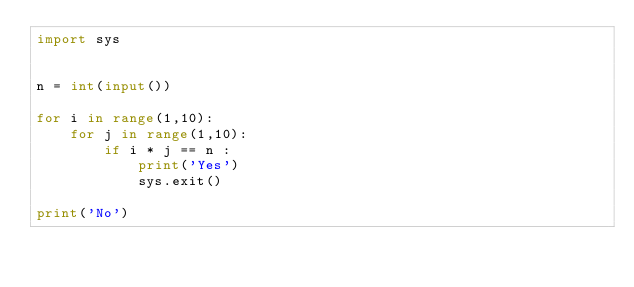<code> <loc_0><loc_0><loc_500><loc_500><_Python_>import sys


n = int(input())

for i in range(1,10):
    for j in range(1,10):
        if i * j == n :
            print('Yes')
            sys.exit()

print('No')</code> 